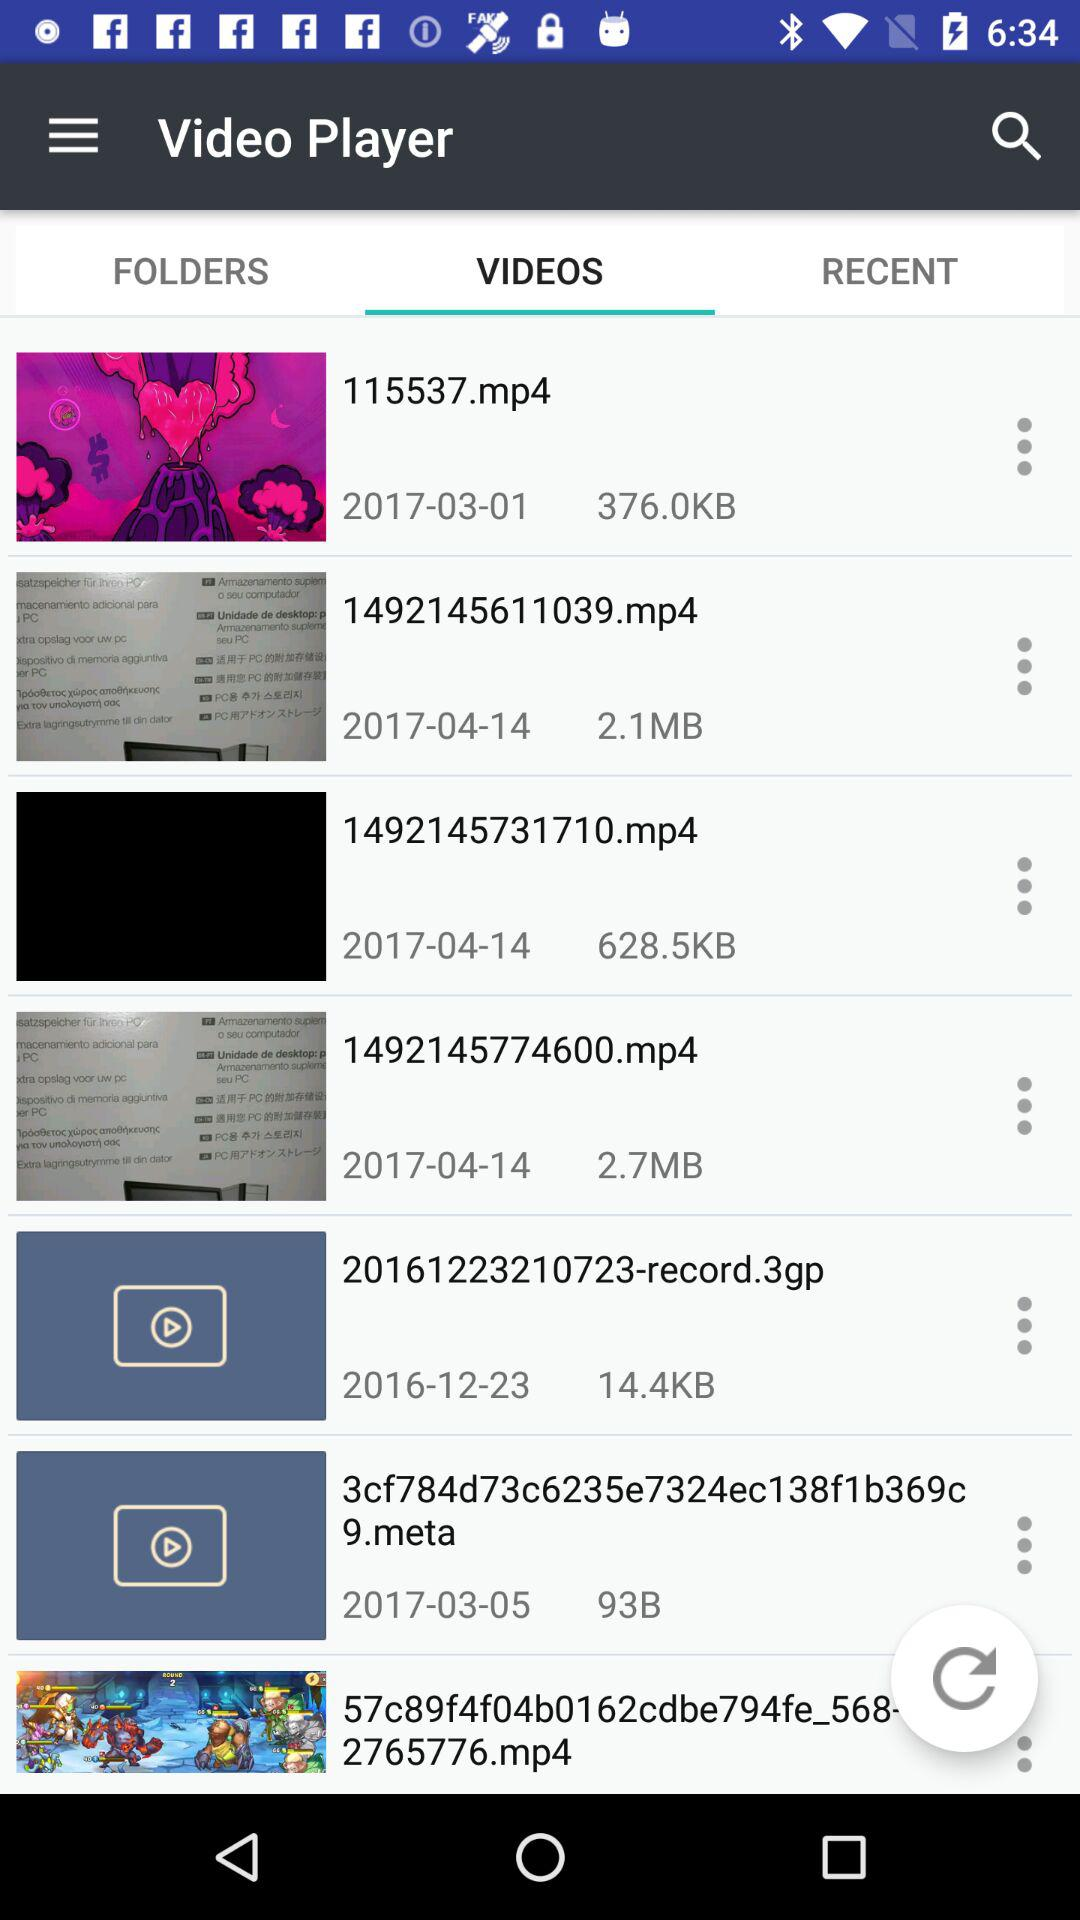Which item has the largest file size?
Answer the question using a single word or phrase. 1492145774600.mp4 